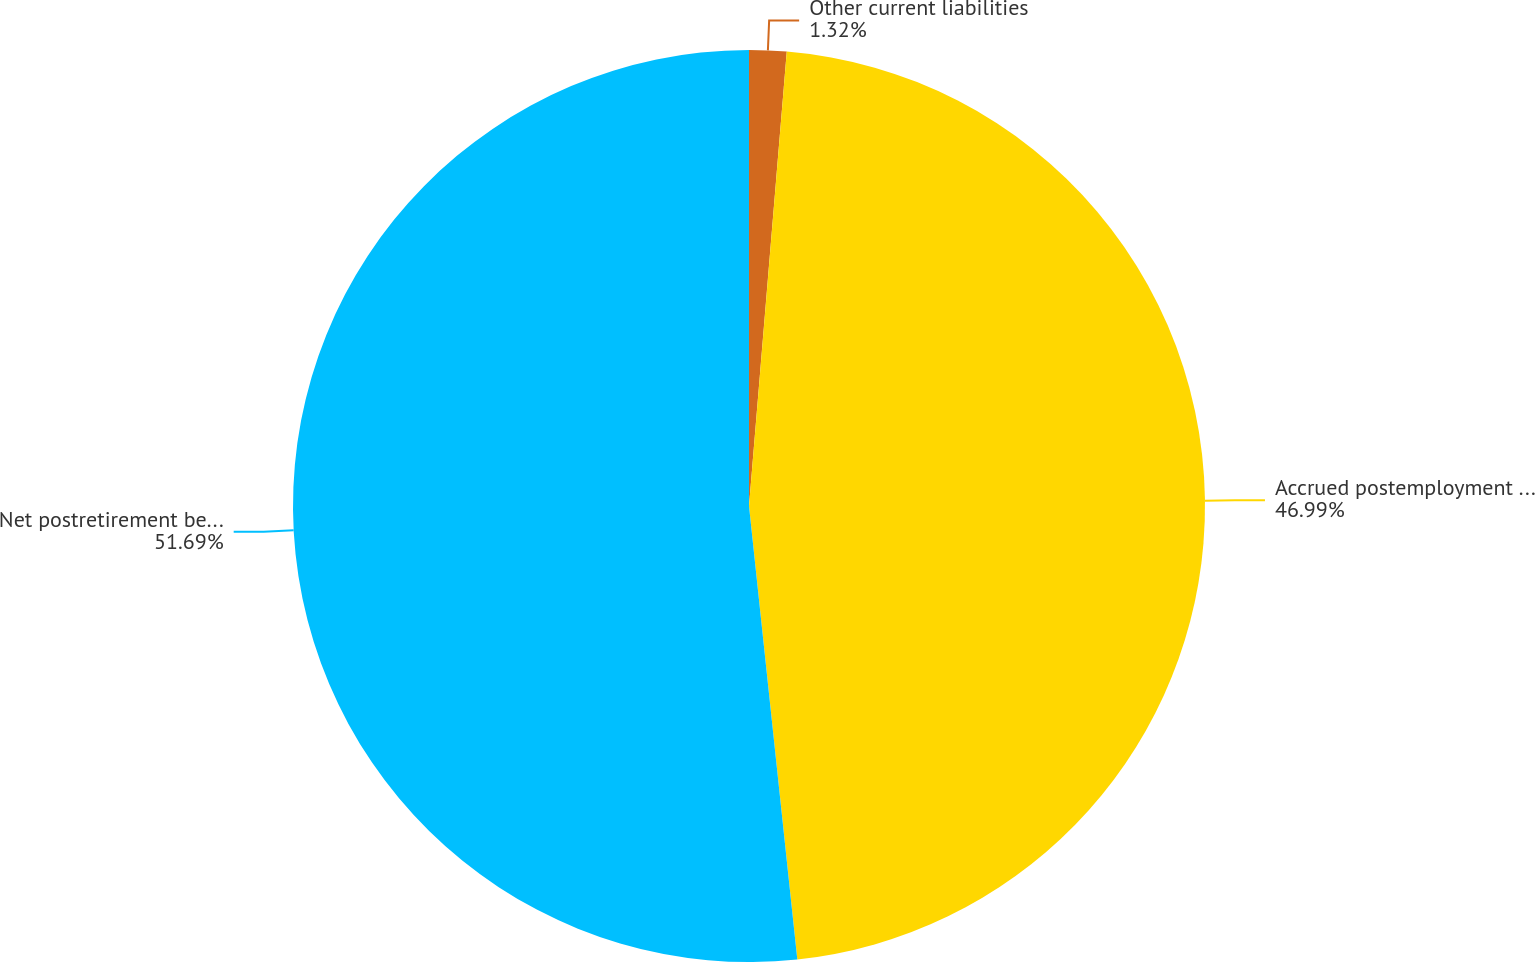Convert chart. <chart><loc_0><loc_0><loc_500><loc_500><pie_chart><fcel>Other current liabilities<fcel>Accrued postemployment costs<fcel>Net postretirement benefit<nl><fcel>1.32%<fcel>46.99%<fcel>51.69%<nl></chart> 